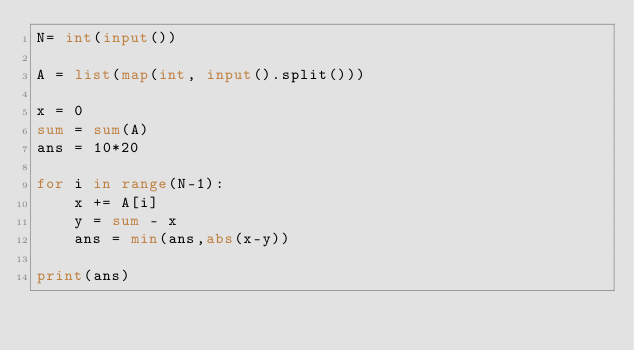Convert code to text. <code><loc_0><loc_0><loc_500><loc_500><_Python_>N= int(input())

A = list(map(int, input().split()))

x = 0
sum = sum(A)
ans = 10*20

for i in range(N-1):
    x += A[i]
    y = sum - x
    ans = min(ans,abs(x-y))

print(ans)
</code> 